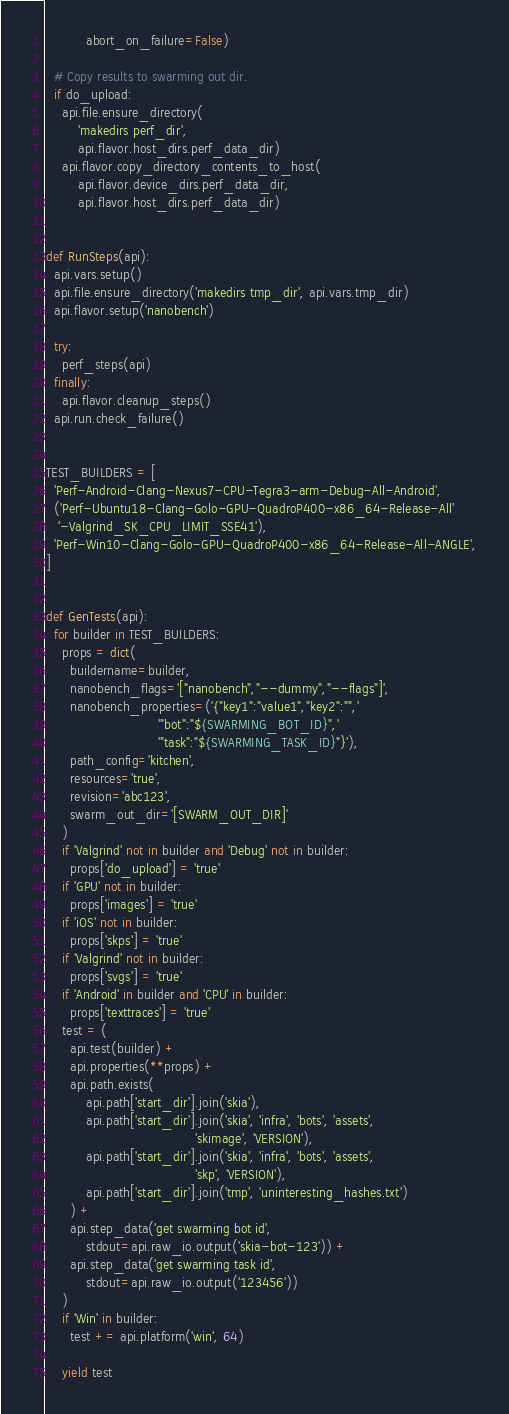<code> <loc_0><loc_0><loc_500><loc_500><_Python_>          abort_on_failure=False)

  # Copy results to swarming out dir.
  if do_upload:
    api.file.ensure_directory(
        'makedirs perf_dir',
        api.flavor.host_dirs.perf_data_dir)
    api.flavor.copy_directory_contents_to_host(
        api.flavor.device_dirs.perf_data_dir,
        api.flavor.host_dirs.perf_data_dir)


def RunSteps(api):
  api.vars.setup()
  api.file.ensure_directory('makedirs tmp_dir', api.vars.tmp_dir)
  api.flavor.setup('nanobench')

  try:
    perf_steps(api)
  finally:
    api.flavor.cleanup_steps()
  api.run.check_failure()


TEST_BUILDERS = [
  'Perf-Android-Clang-Nexus7-CPU-Tegra3-arm-Debug-All-Android',
  ('Perf-Ubuntu18-Clang-Golo-GPU-QuadroP400-x86_64-Release-All'
   '-Valgrind_SK_CPU_LIMIT_SSE41'),
  'Perf-Win10-Clang-Golo-GPU-QuadroP400-x86_64-Release-All-ANGLE',
]


def GenTests(api):
  for builder in TEST_BUILDERS:
    props = dict(
      buildername=builder,
      nanobench_flags='["nanobench","--dummy","--flags"]',
      nanobench_properties=('{"key1":"value1","key2":"",'
                            '"bot":"${SWARMING_BOT_ID}",'
                            '"task":"${SWARMING_TASK_ID}"}'),
      path_config='kitchen',
      resources='true',
      revision='abc123',
      swarm_out_dir='[SWARM_OUT_DIR]'
    )
    if 'Valgrind' not in builder and 'Debug' not in builder:
      props['do_upload'] = 'true'
    if 'GPU' not in builder:
      props['images'] = 'true'
    if 'iOS' not in builder:
      props['skps'] = 'true'
    if 'Valgrind' not in builder:
      props['svgs'] = 'true'
    if 'Android' in builder and 'CPU' in builder:
      props['texttraces'] = 'true'
    test = (
      api.test(builder) +
      api.properties(**props) +
      api.path.exists(
          api.path['start_dir'].join('skia'),
          api.path['start_dir'].join('skia', 'infra', 'bots', 'assets',
                                     'skimage', 'VERSION'),
          api.path['start_dir'].join('skia', 'infra', 'bots', 'assets',
                                     'skp', 'VERSION'),
          api.path['start_dir'].join('tmp', 'uninteresting_hashes.txt')
      ) +
      api.step_data('get swarming bot id',
          stdout=api.raw_io.output('skia-bot-123')) +
      api.step_data('get swarming task id',
          stdout=api.raw_io.output('123456'))
    )
    if 'Win' in builder:
      test += api.platform('win', 64)

    yield test
</code> 